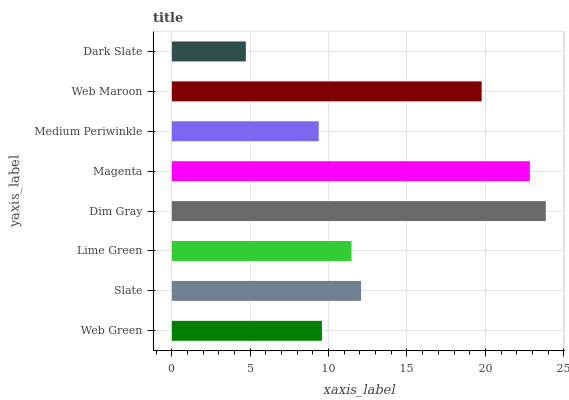Is Dark Slate the minimum?
Answer yes or no. Yes. Is Dim Gray the maximum?
Answer yes or no. Yes. Is Slate the minimum?
Answer yes or no. No. Is Slate the maximum?
Answer yes or no. No. Is Slate greater than Web Green?
Answer yes or no. Yes. Is Web Green less than Slate?
Answer yes or no. Yes. Is Web Green greater than Slate?
Answer yes or no. No. Is Slate less than Web Green?
Answer yes or no. No. Is Slate the high median?
Answer yes or no. Yes. Is Lime Green the low median?
Answer yes or no. Yes. Is Dim Gray the high median?
Answer yes or no. No. Is Web Green the low median?
Answer yes or no. No. 